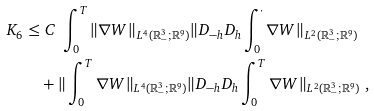<formula> <loc_0><loc_0><loc_500><loc_500>K _ { 6 } \leq & \ C \ \int _ { 0 } ^ { T } \| \nabla { W } \| _ { L ^ { 4 } ( { \mathbb { R } } ^ { 3 } _ { - } ; { \mathbb { R } } ^ { 9 } ) } \| D _ { - h } D _ { h } \int _ { 0 } ^ { \cdot } { \nabla W } \| _ { L ^ { 2 } ( { \mathbb { R } } ^ { 3 } _ { - } ; { \mathbb { R } } ^ { 9 } ) } \\ & + \| \int _ { 0 } ^ { T } \nabla { W } \| _ { L ^ { 4 } ( { \mathbb { R } } ^ { 3 } _ { - } ; { \mathbb { R } } ^ { 9 } ) } \| D _ { - h } D _ { h } \int _ { 0 } ^ { T } \nabla { W } \| _ { L ^ { 2 } ( { \mathbb { R } } ^ { 3 } _ { - } ; { \mathbb { R } } ^ { 9 } ) } \ ,</formula> 